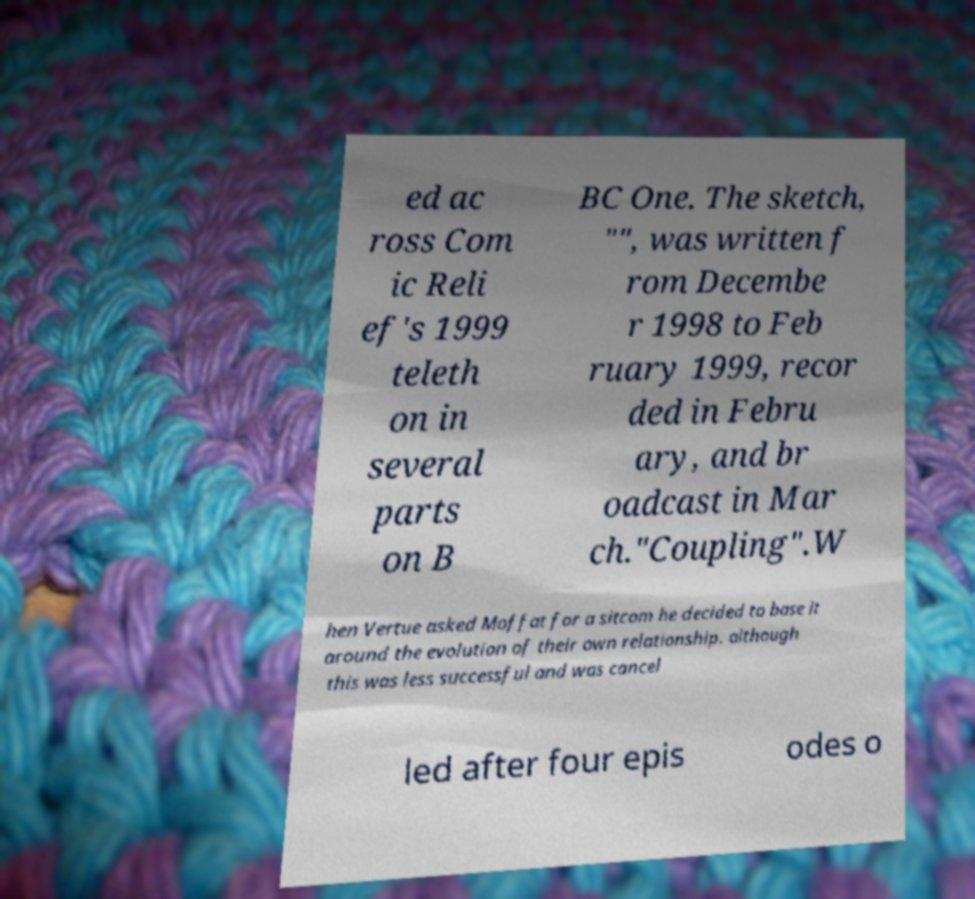I need the written content from this picture converted into text. Can you do that? ed ac ross Com ic Reli ef's 1999 teleth on in several parts on B BC One. The sketch, "", was written f rom Decembe r 1998 to Feb ruary 1999, recor ded in Febru ary, and br oadcast in Mar ch."Coupling".W hen Vertue asked Moffat for a sitcom he decided to base it around the evolution of their own relationship. although this was less successful and was cancel led after four epis odes o 